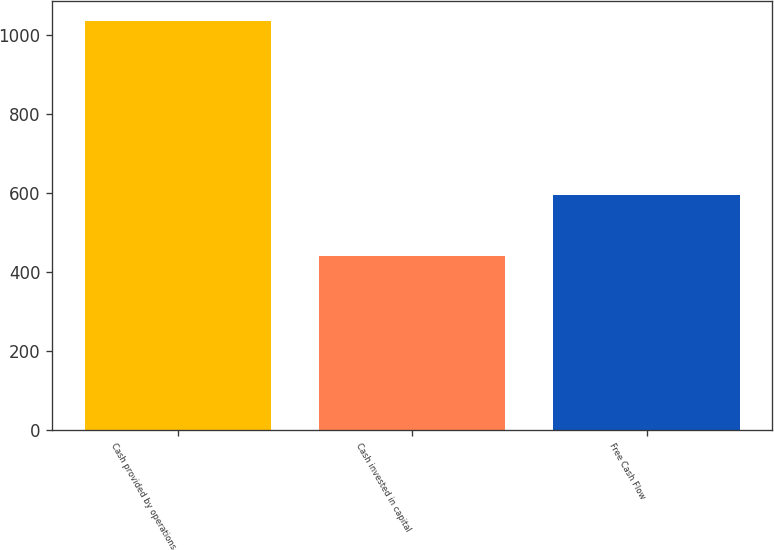<chart> <loc_0><loc_0><loc_500><loc_500><bar_chart><fcel>Cash provided by operations<fcel>Cash invested in capital<fcel>Free Cash Flow<nl><fcel>1034<fcel>439<fcel>595<nl></chart> 